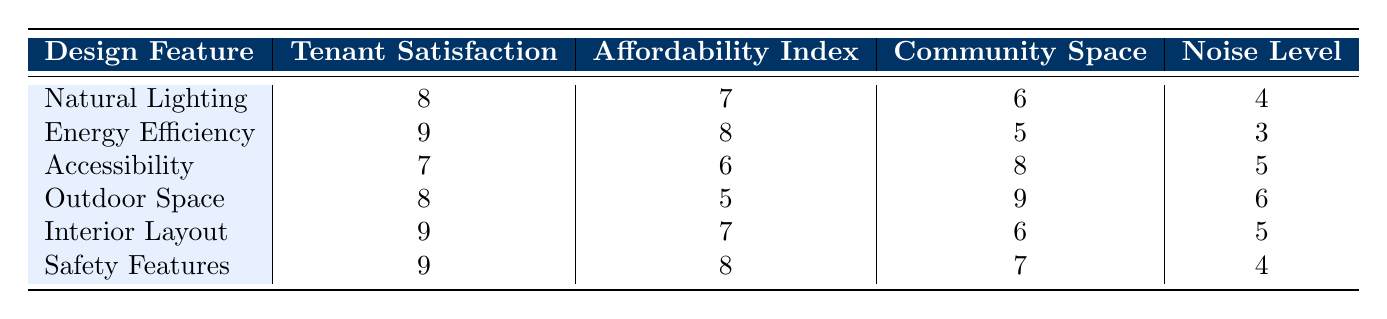What is the tenant satisfaction score for Energy Efficiency? The tenant satisfaction score for the feature "Energy Efficiency" can be directly found in the table, which states it is 9.
Answer: 9 What is the noise level associated with Outdoor Space? The table lists the noise level for "Outdoor Space" as 6, which is a value we can retrieve directly from the row of that design feature.
Answer: 6 Which design feature has the highest tenant satisfaction score? Among all the design features listed, "Energy Efficiency," "Interior Layout," and "Safety Features" each have the highest tenant satisfaction score of 9.
Answer: Energy Efficiency, Interior Layout, Safety Features What is the average affordability index for all design features? To calculate the average affordability index, we first sum the individual scores: (7 + 8 + 6 + 5 + 7 + 8) = 41, then divide by the number of features (6): 41 / 6 = 6.83 (rounded to two decimal places).
Answer: 6.83 Does Accessibility have a higher noise level than Natural Lighting? By comparing the noise levels from the table, Accessibility has a noise level of 5 while Natural Lighting has a noise level of 4. Since 5 is greater than 4, the statement is true.
Answer: Yes What is the difference in tenant satisfaction between the design features with the highest and lowest scores? The highest tenant satisfaction score is 9 (for Energy Efficiency, Interior Layout, and Safety Features), and the lowest score is 7 (for Accessibility). The difference is calculated as 9 - 7 = 2.
Answer: 2 Is the community space higher for Outdoor Space than for Accessibility? From the table, the community space for Outdoor Space is 9, while for Accessibility it is 8, indicating that Outdoor Space indeed has a higher value.
Answer: Yes Which design feature has the lowest affordability index, and what is its value? Looking at the affordability index column, "Outdoor Space" has the lowest value of 5 among all the design features.
Answer: Outdoor Space, 5 What is the sum of tenant satisfaction scores for features with an affordability index of 8? The features with an affordability index of 8 are "Energy Efficiency" and "Safety Features," which have tenant satisfaction scores of 9 each. Adding these together gives 9 + 9 = 18.
Answer: 18 